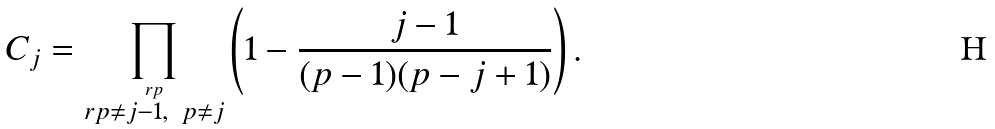<formula> <loc_0><loc_0><loc_500><loc_500>C _ { j } = \prod _ { \stackrel { r p } { r p \neq j - 1 , \ p \neq j } } \left ( 1 - \frac { j - 1 } { ( p - 1 ) ( p - j + 1 ) } \right ) .</formula> 